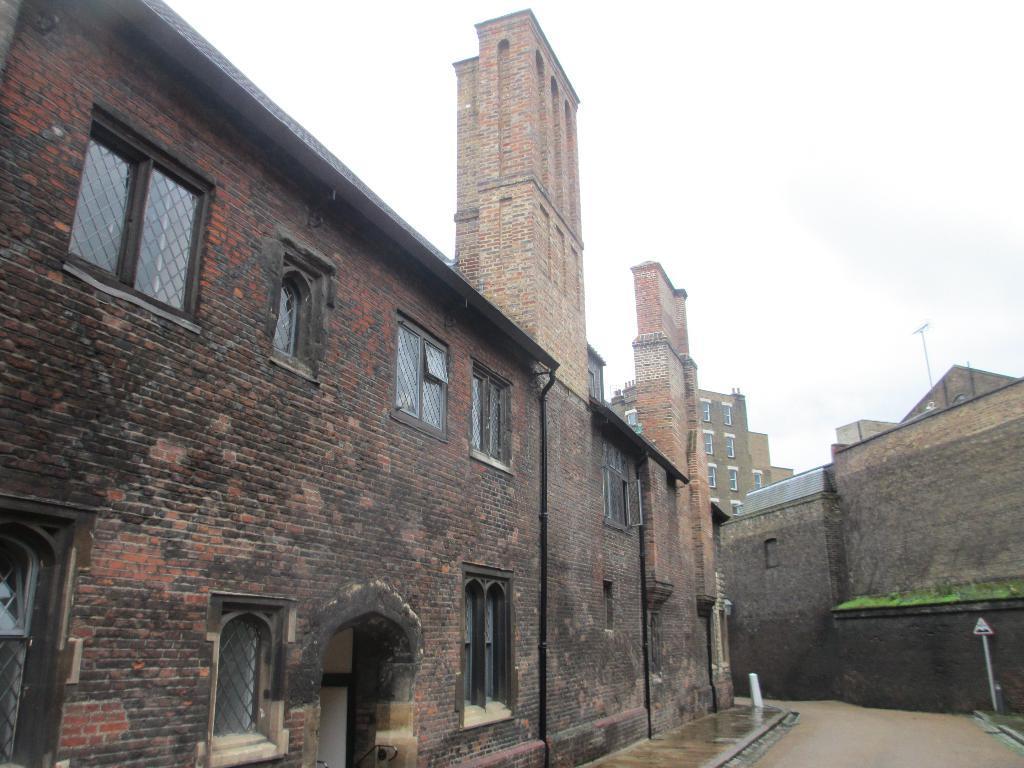Can you describe this image briefly? In this picture we can see the buildings with windows. On the right side of the buildings there is a pole with a signboard. Behind the buildings there is the sky. 